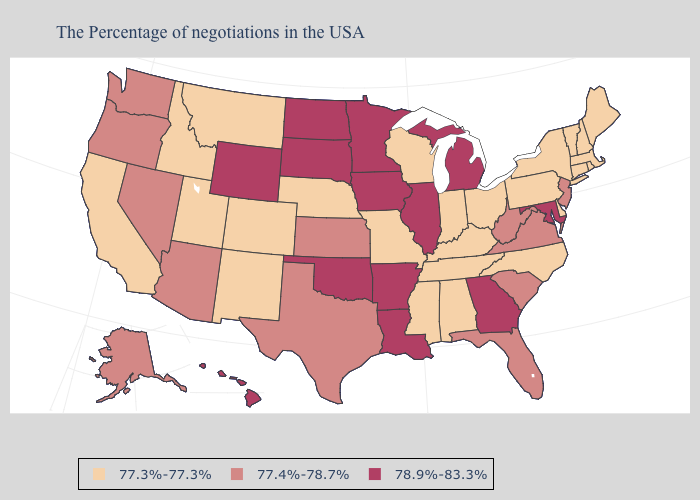What is the value of New York?
Be succinct. 77.3%-77.3%. Does the first symbol in the legend represent the smallest category?
Concise answer only. Yes. Among the states that border Nebraska , which have the highest value?
Give a very brief answer. Iowa, South Dakota, Wyoming. Which states hav the highest value in the South?
Write a very short answer. Maryland, Georgia, Louisiana, Arkansas, Oklahoma. What is the highest value in states that border Arkansas?
Answer briefly. 78.9%-83.3%. How many symbols are there in the legend?
Quick response, please. 3. Name the states that have a value in the range 77.3%-77.3%?
Be succinct. Maine, Massachusetts, Rhode Island, New Hampshire, Vermont, Connecticut, New York, Delaware, Pennsylvania, North Carolina, Ohio, Kentucky, Indiana, Alabama, Tennessee, Wisconsin, Mississippi, Missouri, Nebraska, Colorado, New Mexico, Utah, Montana, Idaho, California. Does Arkansas have the lowest value in the USA?
Answer briefly. No. What is the highest value in the USA?
Concise answer only. 78.9%-83.3%. Does Hawaii have the highest value in the West?
Short answer required. Yes. Does Wyoming have a lower value than New Hampshire?
Write a very short answer. No. Name the states that have a value in the range 77.3%-77.3%?
Short answer required. Maine, Massachusetts, Rhode Island, New Hampshire, Vermont, Connecticut, New York, Delaware, Pennsylvania, North Carolina, Ohio, Kentucky, Indiana, Alabama, Tennessee, Wisconsin, Mississippi, Missouri, Nebraska, Colorado, New Mexico, Utah, Montana, Idaho, California. What is the value of Arizona?
Answer briefly. 77.4%-78.7%. What is the highest value in states that border Texas?
Concise answer only. 78.9%-83.3%. Does the first symbol in the legend represent the smallest category?
Give a very brief answer. Yes. 